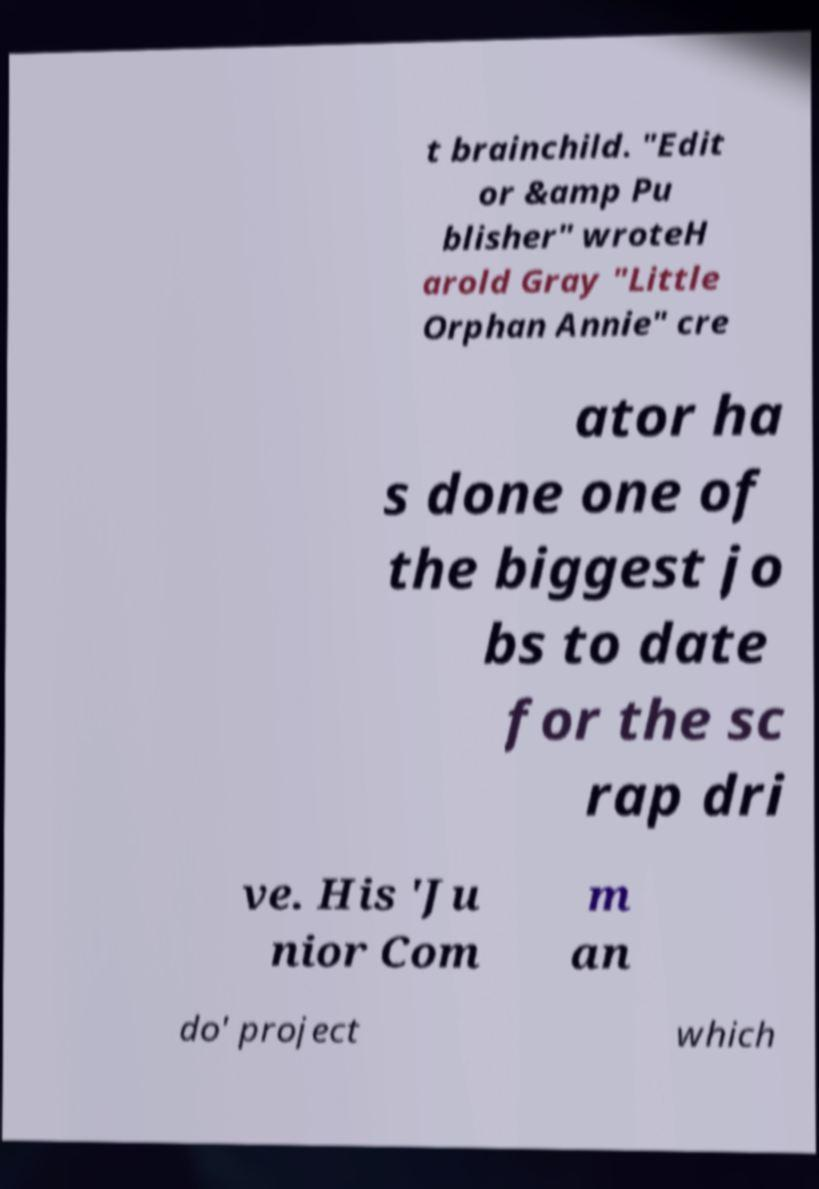I need the written content from this picture converted into text. Can you do that? t brainchild. "Edit or &amp Pu blisher" wroteH arold Gray "Little Orphan Annie" cre ator ha s done one of the biggest jo bs to date for the sc rap dri ve. His 'Ju nior Com m an do' project which 